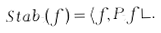Convert formula to latex. <formula><loc_0><loc_0><loc_500><loc_500>S t a b _ { t } ( f ) = \langle f , P _ { t } f \rangle .</formula> 